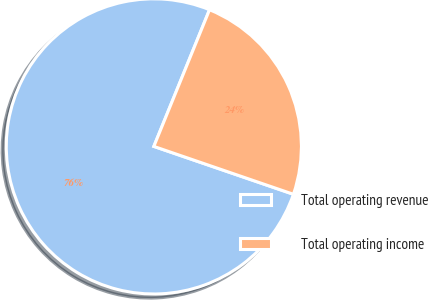<chart> <loc_0><loc_0><loc_500><loc_500><pie_chart><fcel>Total operating revenue<fcel>Total operating income<nl><fcel>75.9%<fcel>24.1%<nl></chart> 